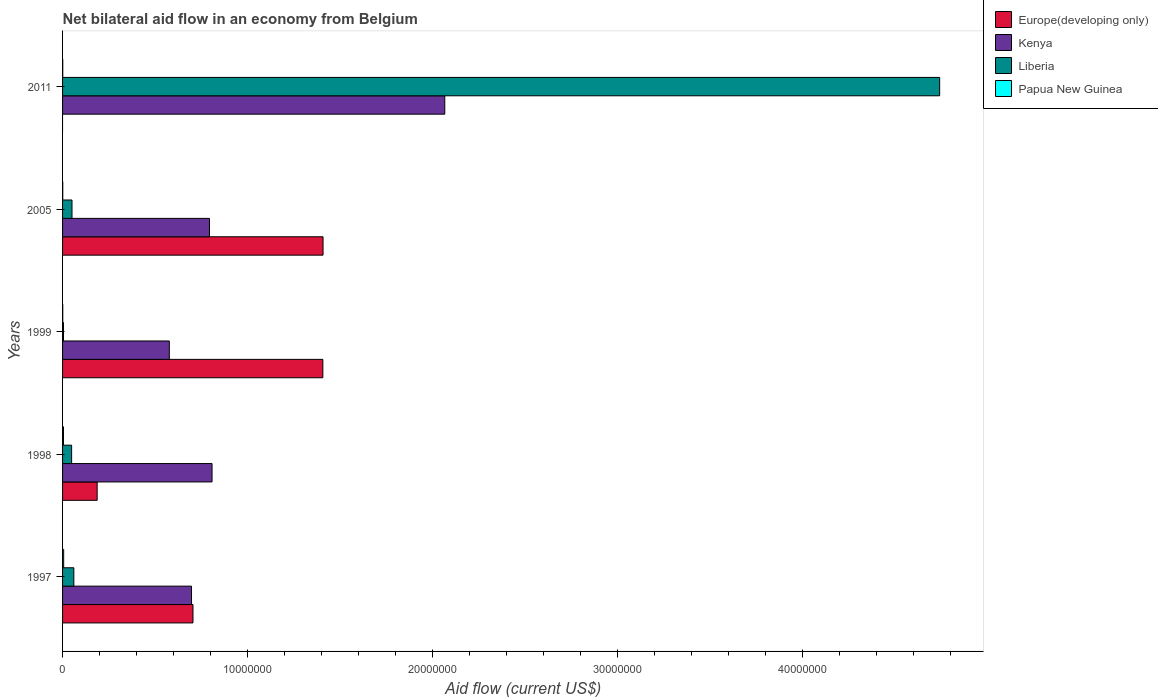How many different coloured bars are there?
Offer a very short reply. 4. What is the label of the 4th group of bars from the top?
Give a very brief answer. 1998. In how many cases, is the number of bars for a given year not equal to the number of legend labels?
Offer a very short reply. 1. What is the net bilateral aid flow in Kenya in 1998?
Offer a terse response. 8.08e+06. Across all years, what is the maximum net bilateral aid flow in Europe(developing only)?
Make the answer very short. 1.41e+07. Across all years, what is the minimum net bilateral aid flow in Liberia?
Your response must be concise. 5.00e+04. What is the total net bilateral aid flow in Kenya in the graph?
Give a very brief answer. 4.94e+07. What is the difference between the net bilateral aid flow in Liberia in 2011 and the net bilateral aid flow in Europe(developing only) in 1999?
Your answer should be very brief. 3.33e+07. What is the average net bilateral aid flow in Kenya per year?
Make the answer very short. 9.88e+06. In the year 1998, what is the difference between the net bilateral aid flow in Papua New Guinea and net bilateral aid flow in Kenya?
Your response must be concise. -8.03e+06. What is the ratio of the net bilateral aid flow in Europe(developing only) in 1997 to that in 2005?
Your response must be concise. 0.5. What is the difference between the highest and the lowest net bilateral aid flow in Kenya?
Make the answer very short. 1.49e+07. In how many years, is the net bilateral aid flow in Kenya greater than the average net bilateral aid flow in Kenya taken over all years?
Provide a short and direct response. 1. Is the sum of the net bilateral aid flow in Liberia in 1997 and 2011 greater than the maximum net bilateral aid flow in Kenya across all years?
Your answer should be very brief. Yes. Is it the case that in every year, the sum of the net bilateral aid flow in Liberia and net bilateral aid flow in Kenya is greater than the sum of net bilateral aid flow in Papua New Guinea and net bilateral aid flow in Europe(developing only)?
Provide a short and direct response. No. Is it the case that in every year, the sum of the net bilateral aid flow in Kenya and net bilateral aid flow in Papua New Guinea is greater than the net bilateral aid flow in Liberia?
Provide a succinct answer. No. How many bars are there?
Give a very brief answer. 19. Are all the bars in the graph horizontal?
Offer a very short reply. Yes. How many years are there in the graph?
Your answer should be very brief. 5. What is the difference between two consecutive major ticks on the X-axis?
Your answer should be very brief. 1.00e+07. Are the values on the major ticks of X-axis written in scientific E-notation?
Keep it short and to the point. No. Does the graph contain grids?
Offer a terse response. No. Where does the legend appear in the graph?
Your answer should be very brief. Top right. How many legend labels are there?
Your answer should be very brief. 4. What is the title of the graph?
Ensure brevity in your answer.  Net bilateral aid flow in an economy from Belgium. Does "Liechtenstein" appear as one of the legend labels in the graph?
Your response must be concise. No. What is the Aid flow (current US$) in Europe(developing only) in 1997?
Your response must be concise. 7.05e+06. What is the Aid flow (current US$) of Kenya in 1997?
Ensure brevity in your answer.  6.97e+06. What is the Aid flow (current US$) in Europe(developing only) in 1998?
Your answer should be compact. 1.87e+06. What is the Aid flow (current US$) of Kenya in 1998?
Offer a terse response. 8.08e+06. What is the Aid flow (current US$) of Liberia in 1998?
Provide a short and direct response. 4.90e+05. What is the Aid flow (current US$) in Europe(developing only) in 1999?
Offer a very short reply. 1.41e+07. What is the Aid flow (current US$) in Kenya in 1999?
Keep it short and to the point. 5.77e+06. What is the Aid flow (current US$) in Liberia in 1999?
Provide a short and direct response. 5.00e+04. What is the Aid flow (current US$) of Europe(developing only) in 2005?
Your answer should be very brief. 1.41e+07. What is the Aid flow (current US$) in Kenya in 2005?
Your answer should be compact. 7.94e+06. What is the Aid flow (current US$) of Liberia in 2005?
Provide a succinct answer. 5.10e+05. What is the Aid flow (current US$) of Europe(developing only) in 2011?
Make the answer very short. 0. What is the Aid flow (current US$) of Kenya in 2011?
Ensure brevity in your answer.  2.07e+07. What is the Aid flow (current US$) in Liberia in 2011?
Ensure brevity in your answer.  4.74e+07. What is the Aid flow (current US$) of Papua New Guinea in 2011?
Give a very brief answer. 10000. Across all years, what is the maximum Aid flow (current US$) of Europe(developing only)?
Keep it short and to the point. 1.41e+07. Across all years, what is the maximum Aid flow (current US$) of Kenya?
Provide a succinct answer. 2.07e+07. Across all years, what is the maximum Aid flow (current US$) in Liberia?
Give a very brief answer. 4.74e+07. Across all years, what is the minimum Aid flow (current US$) in Kenya?
Give a very brief answer. 5.77e+06. What is the total Aid flow (current US$) in Europe(developing only) in the graph?
Ensure brevity in your answer.  3.71e+07. What is the total Aid flow (current US$) of Kenya in the graph?
Provide a succinct answer. 4.94e+07. What is the total Aid flow (current US$) in Liberia in the graph?
Your answer should be compact. 4.91e+07. What is the difference between the Aid flow (current US$) of Europe(developing only) in 1997 and that in 1998?
Ensure brevity in your answer.  5.18e+06. What is the difference between the Aid flow (current US$) in Kenya in 1997 and that in 1998?
Your response must be concise. -1.11e+06. What is the difference between the Aid flow (current US$) of Liberia in 1997 and that in 1998?
Your answer should be compact. 1.20e+05. What is the difference between the Aid flow (current US$) in Europe(developing only) in 1997 and that in 1999?
Ensure brevity in your answer.  -7.02e+06. What is the difference between the Aid flow (current US$) of Kenya in 1997 and that in 1999?
Ensure brevity in your answer.  1.20e+06. What is the difference between the Aid flow (current US$) in Liberia in 1997 and that in 1999?
Your answer should be very brief. 5.60e+05. What is the difference between the Aid flow (current US$) in Papua New Guinea in 1997 and that in 1999?
Ensure brevity in your answer.  5.00e+04. What is the difference between the Aid flow (current US$) in Europe(developing only) in 1997 and that in 2005?
Provide a short and direct response. -7.03e+06. What is the difference between the Aid flow (current US$) in Kenya in 1997 and that in 2005?
Your response must be concise. -9.70e+05. What is the difference between the Aid flow (current US$) in Liberia in 1997 and that in 2005?
Your response must be concise. 1.00e+05. What is the difference between the Aid flow (current US$) in Papua New Guinea in 1997 and that in 2005?
Your answer should be very brief. 5.00e+04. What is the difference between the Aid flow (current US$) in Kenya in 1997 and that in 2011?
Offer a terse response. -1.37e+07. What is the difference between the Aid flow (current US$) of Liberia in 1997 and that in 2011?
Provide a succinct answer. -4.68e+07. What is the difference between the Aid flow (current US$) of Papua New Guinea in 1997 and that in 2011?
Offer a terse response. 5.00e+04. What is the difference between the Aid flow (current US$) of Europe(developing only) in 1998 and that in 1999?
Give a very brief answer. -1.22e+07. What is the difference between the Aid flow (current US$) in Kenya in 1998 and that in 1999?
Your answer should be compact. 2.31e+06. What is the difference between the Aid flow (current US$) of Papua New Guinea in 1998 and that in 1999?
Your answer should be very brief. 4.00e+04. What is the difference between the Aid flow (current US$) in Europe(developing only) in 1998 and that in 2005?
Provide a short and direct response. -1.22e+07. What is the difference between the Aid flow (current US$) of Kenya in 1998 and that in 2005?
Keep it short and to the point. 1.40e+05. What is the difference between the Aid flow (current US$) of Papua New Guinea in 1998 and that in 2005?
Your answer should be compact. 4.00e+04. What is the difference between the Aid flow (current US$) of Kenya in 1998 and that in 2011?
Your answer should be compact. -1.26e+07. What is the difference between the Aid flow (current US$) of Liberia in 1998 and that in 2011?
Make the answer very short. -4.69e+07. What is the difference between the Aid flow (current US$) of Papua New Guinea in 1998 and that in 2011?
Provide a succinct answer. 4.00e+04. What is the difference between the Aid flow (current US$) of Kenya in 1999 and that in 2005?
Ensure brevity in your answer.  -2.17e+06. What is the difference between the Aid flow (current US$) in Liberia in 1999 and that in 2005?
Offer a very short reply. -4.60e+05. What is the difference between the Aid flow (current US$) in Papua New Guinea in 1999 and that in 2005?
Keep it short and to the point. 0. What is the difference between the Aid flow (current US$) in Kenya in 1999 and that in 2011?
Make the answer very short. -1.49e+07. What is the difference between the Aid flow (current US$) in Liberia in 1999 and that in 2011?
Your answer should be compact. -4.74e+07. What is the difference between the Aid flow (current US$) in Kenya in 2005 and that in 2011?
Provide a short and direct response. -1.27e+07. What is the difference between the Aid flow (current US$) in Liberia in 2005 and that in 2011?
Your response must be concise. -4.69e+07. What is the difference between the Aid flow (current US$) in Europe(developing only) in 1997 and the Aid flow (current US$) in Kenya in 1998?
Keep it short and to the point. -1.03e+06. What is the difference between the Aid flow (current US$) of Europe(developing only) in 1997 and the Aid flow (current US$) of Liberia in 1998?
Offer a very short reply. 6.56e+06. What is the difference between the Aid flow (current US$) of Europe(developing only) in 1997 and the Aid flow (current US$) of Papua New Guinea in 1998?
Provide a succinct answer. 7.00e+06. What is the difference between the Aid flow (current US$) of Kenya in 1997 and the Aid flow (current US$) of Liberia in 1998?
Your answer should be compact. 6.48e+06. What is the difference between the Aid flow (current US$) of Kenya in 1997 and the Aid flow (current US$) of Papua New Guinea in 1998?
Your response must be concise. 6.92e+06. What is the difference between the Aid flow (current US$) in Liberia in 1997 and the Aid flow (current US$) in Papua New Guinea in 1998?
Ensure brevity in your answer.  5.60e+05. What is the difference between the Aid flow (current US$) of Europe(developing only) in 1997 and the Aid flow (current US$) of Kenya in 1999?
Make the answer very short. 1.28e+06. What is the difference between the Aid flow (current US$) of Europe(developing only) in 1997 and the Aid flow (current US$) of Papua New Guinea in 1999?
Offer a very short reply. 7.04e+06. What is the difference between the Aid flow (current US$) in Kenya in 1997 and the Aid flow (current US$) in Liberia in 1999?
Your answer should be compact. 6.92e+06. What is the difference between the Aid flow (current US$) of Kenya in 1997 and the Aid flow (current US$) of Papua New Guinea in 1999?
Make the answer very short. 6.96e+06. What is the difference between the Aid flow (current US$) in Liberia in 1997 and the Aid flow (current US$) in Papua New Guinea in 1999?
Keep it short and to the point. 6.00e+05. What is the difference between the Aid flow (current US$) in Europe(developing only) in 1997 and the Aid flow (current US$) in Kenya in 2005?
Offer a very short reply. -8.90e+05. What is the difference between the Aid flow (current US$) in Europe(developing only) in 1997 and the Aid flow (current US$) in Liberia in 2005?
Make the answer very short. 6.54e+06. What is the difference between the Aid flow (current US$) of Europe(developing only) in 1997 and the Aid flow (current US$) of Papua New Guinea in 2005?
Keep it short and to the point. 7.04e+06. What is the difference between the Aid flow (current US$) of Kenya in 1997 and the Aid flow (current US$) of Liberia in 2005?
Provide a short and direct response. 6.46e+06. What is the difference between the Aid flow (current US$) in Kenya in 1997 and the Aid flow (current US$) in Papua New Guinea in 2005?
Provide a succinct answer. 6.96e+06. What is the difference between the Aid flow (current US$) in Europe(developing only) in 1997 and the Aid flow (current US$) in Kenya in 2011?
Provide a succinct answer. -1.36e+07. What is the difference between the Aid flow (current US$) in Europe(developing only) in 1997 and the Aid flow (current US$) in Liberia in 2011?
Your answer should be compact. -4.04e+07. What is the difference between the Aid flow (current US$) in Europe(developing only) in 1997 and the Aid flow (current US$) in Papua New Guinea in 2011?
Make the answer very short. 7.04e+06. What is the difference between the Aid flow (current US$) in Kenya in 1997 and the Aid flow (current US$) in Liberia in 2011?
Offer a terse response. -4.04e+07. What is the difference between the Aid flow (current US$) in Kenya in 1997 and the Aid flow (current US$) in Papua New Guinea in 2011?
Ensure brevity in your answer.  6.96e+06. What is the difference between the Aid flow (current US$) in Liberia in 1997 and the Aid flow (current US$) in Papua New Guinea in 2011?
Keep it short and to the point. 6.00e+05. What is the difference between the Aid flow (current US$) of Europe(developing only) in 1998 and the Aid flow (current US$) of Kenya in 1999?
Provide a short and direct response. -3.90e+06. What is the difference between the Aid flow (current US$) of Europe(developing only) in 1998 and the Aid flow (current US$) of Liberia in 1999?
Offer a terse response. 1.82e+06. What is the difference between the Aid flow (current US$) in Europe(developing only) in 1998 and the Aid flow (current US$) in Papua New Guinea in 1999?
Provide a succinct answer. 1.86e+06. What is the difference between the Aid flow (current US$) in Kenya in 1998 and the Aid flow (current US$) in Liberia in 1999?
Give a very brief answer. 8.03e+06. What is the difference between the Aid flow (current US$) in Kenya in 1998 and the Aid flow (current US$) in Papua New Guinea in 1999?
Your answer should be compact. 8.07e+06. What is the difference between the Aid flow (current US$) in Europe(developing only) in 1998 and the Aid flow (current US$) in Kenya in 2005?
Provide a short and direct response. -6.07e+06. What is the difference between the Aid flow (current US$) of Europe(developing only) in 1998 and the Aid flow (current US$) of Liberia in 2005?
Your response must be concise. 1.36e+06. What is the difference between the Aid flow (current US$) in Europe(developing only) in 1998 and the Aid flow (current US$) in Papua New Guinea in 2005?
Keep it short and to the point. 1.86e+06. What is the difference between the Aid flow (current US$) of Kenya in 1998 and the Aid flow (current US$) of Liberia in 2005?
Keep it short and to the point. 7.57e+06. What is the difference between the Aid flow (current US$) of Kenya in 1998 and the Aid flow (current US$) of Papua New Guinea in 2005?
Offer a terse response. 8.07e+06. What is the difference between the Aid flow (current US$) in Liberia in 1998 and the Aid flow (current US$) in Papua New Guinea in 2005?
Keep it short and to the point. 4.80e+05. What is the difference between the Aid flow (current US$) of Europe(developing only) in 1998 and the Aid flow (current US$) of Kenya in 2011?
Make the answer very short. -1.88e+07. What is the difference between the Aid flow (current US$) in Europe(developing only) in 1998 and the Aid flow (current US$) in Liberia in 2011?
Your response must be concise. -4.55e+07. What is the difference between the Aid flow (current US$) of Europe(developing only) in 1998 and the Aid flow (current US$) of Papua New Guinea in 2011?
Offer a terse response. 1.86e+06. What is the difference between the Aid flow (current US$) in Kenya in 1998 and the Aid flow (current US$) in Liberia in 2011?
Offer a terse response. -3.93e+07. What is the difference between the Aid flow (current US$) in Kenya in 1998 and the Aid flow (current US$) in Papua New Guinea in 2011?
Provide a short and direct response. 8.07e+06. What is the difference between the Aid flow (current US$) in Europe(developing only) in 1999 and the Aid flow (current US$) in Kenya in 2005?
Ensure brevity in your answer.  6.13e+06. What is the difference between the Aid flow (current US$) in Europe(developing only) in 1999 and the Aid flow (current US$) in Liberia in 2005?
Give a very brief answer. 1.36e+07. What is the difference between the Aid flow (current US$) of Europe(developing only) in 1999 and the Aid flow (current US$) of Papua New Guinea in 2005?
Keep it short and to the point. 1.41e+07. What is the difference between the Aid flow (current US$) in Kenya in 1999 and the Aid flow (current US$) in Liberia in 2005?
Offer a very short reply. 5.26e+06. What is the difference between the Aid flow (current US$) in Kenya in 1999 and the Aid flow (current US$) in Papua New Guinea in 2005?
Give a very brief answer. 5.76e+06. What is the difference between the Aid flow (current US$) in Liberia in 1999 and the Aid flow (current US$) in Papua New Guinea in 2005?
Your answer should be very brief. 4.00e+04. What is the difference between the Aid flow (current US$) of Europe(developing only) in 1999 and the Aid flow (current US$) of Kenya in 2011?
Provide a succinct answer. -6.59e+06. What is the difference between the Aid flow (current US$) of Europe(developing only) in 1999 and the Aid flow (current US$) of Liberia in 2011?
Offer a terse response. -3.33e+07. What is the difference between the Aid flow (current US$) of Europe(developing only) in 1999 and the Aid flow (current US$) of Papua New Guinea in 2011?
Your answer should be compact. 1.41e+07. What is the difference between the Aid flow (current US$) in Kenya in 1999 and the Aid flow (current US$) in Liberia in 2011?
Offer a terse response. -4.16e+07. What is the difference between the Aid flow (current US$) in Kenya in 1999 and the Aid flow (current US$) in Papua New Guinea in 2011?
Keep it short and to the point. 5.76e+06. What is the difference between the Aid flow (current US$) of Liberia in 1999 and the Aid flow (current US$) of Papua New Guinea in 2011?
Your answer should be compact. 4.00e+04. What is the difference between the Aid flow (current US$) of Europe(developing only) in 2005 and the Aid flow (current US$) of Kenya in 2011?
Provide a short and direct response. -6.58e+06. What is the difference between the Aid flow (current US$) of Europe(developing only) in 2005 and the Aid flow (current US$) of Liberia in 2011?
Ensure brevity in your answer.  -3.33e+07. What is the difference between the Aid flow (current US$) of Europe(developing only) in 2005 and the Aid flow (current US$) of Papua New Guinea in 2011?
Your response must be concise. 1.41e+07. What is the difference between the Aid flow (current US$) of Kenya in 2005 and the Aid flow (current US$) of Liberia in 2011?
Offer a very short reply. -3.95e+07. What is the difference between the Aid flow (current US$) in Kenya in 2005 and the Aid flow (current US$) in Papua New Guinea in 2011?
Provide a succinct answer. 7.93e+06. What is the average Aid flow (current US$) of Europe(developing only) per year?
Your response must be concise. 7.41e+06. What is the average Aid flow (current US$) of Kenya per year?
Keep it short and to the point. 9.88e+06. What is the average Aid flow (current US$) in Liberia per year?
Offer a terse response. 9.81e+06. What is the average Aid flow (current US$) in Papua New Guinea per year?
Provide a succinct answer. 2.80e+04. In the year 1997, what is the difference between the Aid flow (current US$) of Europe(developing only) and Aid flow (current US$) of Liberia?
Offer a terse response. 6.44e+06. In the year 1997, what is the difference between the Aid flow (current US$) in Europe(developing only) and Aid flow (current US$) in Papua New Guinea?
Your answer should be very brief. 6.99e+06. In the year 1997, what is the difference between the Aid flow (current US$) of Kenya and Aid flow (current US$) of Liberia?
Your answer should be compact. 6.36e+06. In the year 1997, what is the difference between the Aid flow (current US$) of Kenya and Aid flow (current US$) of Papua New Guinea?
Keep it short and to the point. 6.91e+06. In the year 1997, what is the difference between the Aid flow (current US$) in Liberia and Aid flow (current US$) in Papua New Guinea?
Ensure brevity in your answer.  5.50e+05. In the year 1998, what is the difference between the Aid flow (current US$) in Europe(developing only) and Aid flow (current US$) in Kenya?
Your answer should be compact. -6.21e+06. In the year 1998, what is the difference between the Aid flow (current US$) in Europe(developing only) and Aid flow (current US$) in Liberia?
Offer a very short reply. 1.38e+06. In the year 1998, what is the difference between the Aid flow (current US$) in Europe(developing only) and Aid flow (current US$) in Papua New Guinea?
Your response must be concise. 1.82e+06. In the year 1998, what is the difference between the Aid flow (current US$) of Kenya and Aid flow (current US$) of Liberia?
Ensure brevity in your answer.  7.59e+06. In the year 1998, what is the difference between the Aid flow (current US$) of Kenya and Aid flow (current US$) of Papua New Guinea?
Provide a short and direct response. 8.03e+06. In the year 1999, what is the difference between the Aid flow (current US$) of Europe(developing only) and Aid flow (current US$) of Kenya?
Provide a succinct answer. 8.30e+06. In the year 1999, what is the difference between the Aid flow (current US$) in Europe(developing only) and Aid flow (current US$) in Liberia?
Offer a terse response. 1.40e+07. In the year 1999, what is the difference between the Aid flow (current US$) in Europe(developing only) and Aid flow (current US$) in Papua New Guinea?
Your answer should be compact. 1.41e+07. In the year 1999, what is the difference between the Aid flow (current US$) of Kenya and Aid flow (current US$) of Liberia?
Make the answer very short. 5.72e+06. In the year 1999, what is the difference between the Aid flow (current US$) in Kenya and Aid flow (current US$) in Papua New Guinea?
Your response must be concise. 5.76e+06. In the year 2005, what is the difference between the Aid flow (current US$) in Europe(developing only) and Aid flow (current US$) in Kenya?
Your answer should be compact. 6.14e+06. In the year 2005, what is the difference between the Aid flow (current US$) of Europe(developing only) and Aid flow (current US$) of Liberia?
Give a very brief answer. 1.36e+07. In the year 2005, what is the difference between the Aid flow (current US$) in Europe(developing only) and Aid flow (current US$) in Papua New Guinea?
Provide a short and direct response. 1.41e+07. In the year 2005, what is the difference between the Aid flow (current US$) of Kenya and Aid flow (current US$) of Liberia?
Your answer should be very brief. 7.43e+06. In the year 2005, what is the difference between the Aid flow (current US$) of Kenya and Aid flow (current US$) of Papua New Guinea?
Provide a succinct answer. 7.93e+06. In the year 2011, what is the difference between the Aid flow (current US$) in Kenya and Aid flow (current US$) in Liberia?
Provide a short and direct response. -2.68e+07. In the year 2011, what is the difference between the Aid flow (current US$) of Kenya and Aid flow (current US$) of Papua New Guinea?
Provide a short and direct response. 2.06e+07. In the year 2011, what is the difference between the Aid flow (current US$) of Liberia and Aid flow (current US$) of Papua New Guinea?
Your answer should be compact. 4.74e+07. What is the ratio of the Aid flow (current US$) in Europe(developing only) in 1997 to that in 1998?
Your answer should be very brief. 3.77. What is the ratio of the Aid flow (current US$) in Kenya in 1997 to that in 1998?
Offer a very short reply. 0.86. What is the ratio of the Aid flow (current US$) in Liberia in 1997 to that in 1998?
Your answer should be compact. 1.24. What is the ratio of the Aid flow (current US$) of Europe(developing only) in 1997 to that in 1999?
Provide a short and direct response. 0.5. What is the ratio of the Aid flow (current US$) of Kenya in 1997 to that in 1999?
Provide a succinct answer. 1.21. What is the ratio of the Aid flow (current US$) in Liberia in 1997 to that in 1999?
Offer a terse response. 12.2. What is the ratio of the Aid flow (current US$) in Papua New Guinea in 1997 to that in 1999?
Make the answer very short. 6. What is the ratio of the Aid flow (current US$) in Europe(developing only) in 1997 to that in 2005?
Give a very brief answer. 0.5. What is the ratio of the Aid flow (current US$) of Kenya in 1997 to that in 2005?
Your response must be concise. 0.88. What is the ratio of the Aid flow (current US$) in Liberia in 1997 to that in 2005?
Make the answer very short. 1.2. What is the ratio of the Aid flow (current US$) of Papua New Guinea in 1997 to that in 2005?
Provide a succinct answer. 6. What is the ratio of the Aid flow (current US$) in Kenya in 1997 to that in 2011?
Ensure brevity in your answer.  0.34. What is the ratio of the Aid flow (current US$) of Liberia in 1997 to that in 2011?
Provide a succinct answer. 0.01. What is the ratio of the Aid flow (current US$) in Papua New Guinea in 1997 to that in 2011?
Ensure brevity in your answer.  6. What is the ratio of the Aid flow (current US$) in Europe(developing only) in 1998 to that in 1999?
Give a very brief answer. 0.13. What is the ratio of the Aid flow (current US$) of Kenya in 1998 to that in 1999?
Provide a succinct answer. 1.4. What is the ratio of the Aid flow (current US$) of Liberia in 1998 to that in 1999?
Offer a very short reply. 9.8. What is the ratio of the Aid flow (current US$) of Europe(developing only) in 1998 to that in 2005?
Your answer should be compact. 0.13. What is the ratio of the Aid flow (current US$) of Kenya in 1998 to that in 2005?
Offer a very short reply. 1.02. What is the ratio of the Aid flow (current US$) in Liberia in 1998 to that in 2005?
Keep it short and to the point. 0.96. What is the ratio of the Aid flow (current US$) of Kenya in 1998 to that in 2011?
Offer a terse response. 0.39. What is the ratio of the Aid flow (current US$) in Liberia in 1998 to that in 2011?
Give a very brief answer. 0.01. What is the ratio of the Aid flow (current US$) in Kenya in 1999 to that in 2005?
Provide a succinct answer. 0.73. What is the ratio of the Aid flow (current US$) of Liberia in 1999 to that in 2005?
Your answer should be compact. 0.1. What is the ratio of the Aid flow (current US$) in Kenya in 1999 to that in 2011?
Offer a very short reply. 0.28. What is the ratio of the Aid flow (current US$) of Liberia in 1999 to that in 2011?
Make the answer very short. 0. What is the ratio of the Aid flow (current US$) in Kenya in 2005 to that in 2011?
Provide a succinct answer. 0.38. What is the ratio of the Aid flow (current US$) of Liberia in 2005 to that in 2011?
Your answer should be very brief. 0.01. What is the difference between the highest and the second highest Aid flow (current US$) in Europe(developing only)?
Offer a terse response. 10000. What is the difference between the highest and the second highest Aid flow (current US$) of Kenya?
Provide a short and direct response. 1.26e+07. What is the difference between the highest and the second highest Aid flow (current US$) in Liberia?
Give a very brief answer. 4.68e+07. What is the difference between the highest and the lowest Aid flow (current US$) of Europe(developing only)?
Keep it short and to the point. 1.41e+07. What is the difference between the highest and the lowest Aid flow (current US$) in Kenya?
Your answer should be compact. 1.49e+07. What is the difference between the highest and the lowest Aid flow (current US$) of Liberia?
Ensure brevity in your answer.  4.74e+07. What is the difference between the highest and the lowest Aid flow (current US$) in Papua New Guinea?
Ensure brevity in your answer.  5.00e+04. 